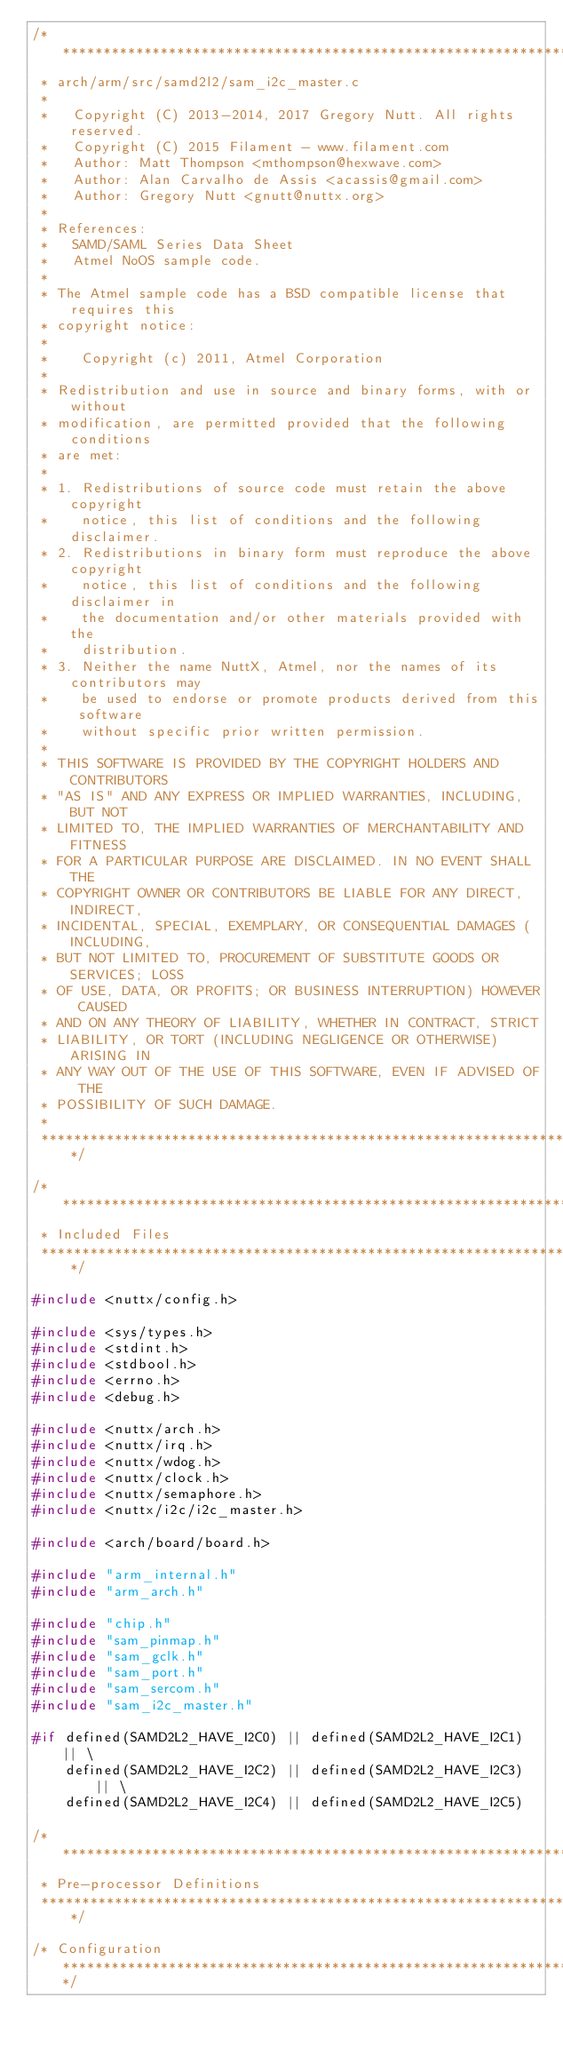<code> <loc_0><loc_0><loc_500><loc_500><_C_>/*******************************************************************************
 * arch/arm/src/samd2l2/sam_i2c_master.c
 *
 *   Copyright (C) 2013-2014, 2017 Gregory Nutt. All rights reserved.
 *   Copyright (C) 2015 Filament - www.filament.com
 *   Author: Matt Thompson <mthompson@hexwave.com>
 *   Author: Alan Carvalho de Assis <acassis@gmail.com>
 *   Author: Gregory Nutt <gnutt@nuttx.org>
 *
 * References:
 *   SAMD/SAML Series Data Sheet
 *   Atmel NoOS sample code.
 *
 * The Atmel sample code has a BSD compatible license that requires this
 * copyright notice:
 *
 *    Copyright (c) 2011, Atmel Corporation
 *
 * Redistribution and use in source and binary forms, with or without
 * modification, are permitted provided that the following conditions
 * are met:
 *
 * 1. Redistributions of source code must retain the above copyright
 *    notice, this list of conditions and the following disclaimer.
 * 2. Redistributions in binary form must reproduce the above copyright
 *    notice, this list of conditions and the following disclaimer in
 *    the documentation and/or other materials provided with the
 *    distribution.
 * 3. Neither the name NuttX, Atmel, nor the names of its contributors may
 *    be used to endorse or promote products derived from this software
 *    without specific prior written permission.
 *
 * THIS SOFTWARE IS PROVIDED BY THE COPYRIGHT HOLDERS AND CONTRIBUTORS
 * "AS IS" AND ANY EXPRESS OR IMPLIED WARRANTIES, INCLUDING, BUT NOT
 * LIMITED TO, THE IMPLIED WARRANTIES OF MERCHANTABILITY AND FITNESS
 * FOR A PARTICULAR PURPOSE ARE DISCLAIMED. IN NO EVENT SHALL THE
 * COPYRIGHT OWNER OR CONTRIBUTORS BE LIABLE FOR ANY DIRECT, INDIRECT,
 * INCIDENTAL, SPECIAL, EXEMPLARY, OR CONSEQUENTIAL DAMAGES (INCLUDING,
 * BUT NOT LIMITED TO, PROCUREMENT OF SUBSTITUTE GOODS OR SERVICES; LOSS
 * OF USE, DATA, OR PROFITS; OR BUSINESS INTERRUPTION) HOWEVER CAUSED
 * AND ON ANY THEORY OF LIABILITY, WHETHER IN CONTRACT, STRICT
 * LIABILITY, OR TORT (INCLUDING NEGLIGENCE OR OTHERWISE) ARISING IN
 * ANY WAY OUT OF THE USE OF THIS SOFTWARE, EVEN IF ADVISED OF THE
 * POSSIBILITY OF SUCH DAMAGE.
 *
 *******************************************************************************/

/*******************************************************************************
 * Included Files
 *******************************************************************************/

#include <nuttx/config.h>

#include <sys/types.h>
#include <stdint.h>
#include <stdbool.h>
#include <errno.h>
#include <debug.h>

#include <nuttx/arch.h>
#include <nuttx/irq.h>
#include <nuttx/wdog.h>
#include <nuttx/clock.h>
#include <nuttx/semaphore.h>
#include <nuttx/i2c/i2c_master.h>

#include <arch/board/board.h>

#include "arm_internal.h"
#include "arm_arch.h"

#include "chip.h"
#include "sam_pinmap.h"
#include "sam_gclk.h"
#include "sam_port.h"
#include "sam_sercom.h"
#include "sam_i2c_master.h"

#if defined(SAMD2L2_HAVE_I2C0) || defined(SAMD2L2_HAVE_I2C1) || \
    defined(SAMD2L2_HAVE_I2C2) || defined(SAMD2L2_HAVE_I2C3) || \
    defined(SAMD2L2_HAVE_I2C4) || defined(SAMD2L2_HAVE_I2C5)

/*******************************************************************************
 * Pre-processor Definitions
 *******************************************************************************/

/* Configuration ***************************************************************/
</code> 